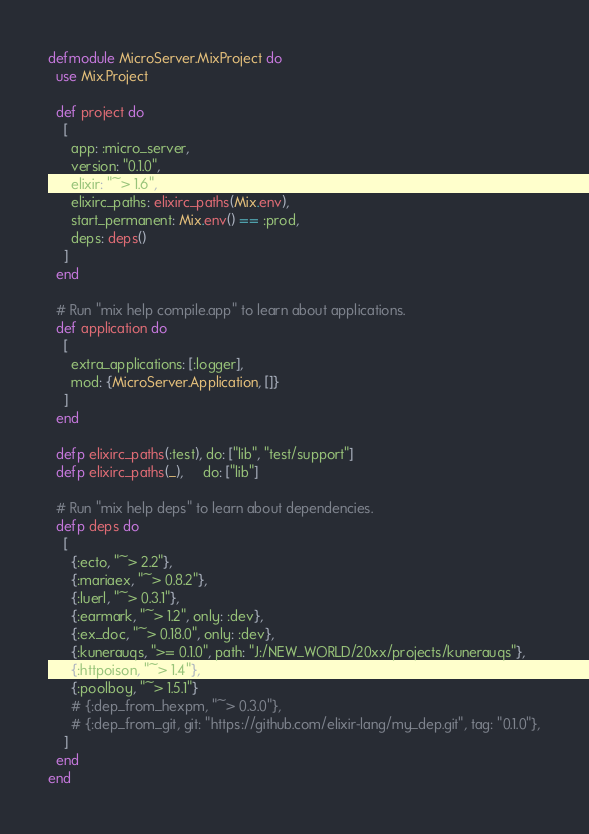Convert code to text. <code><loc_0><loc_0><loc_500><loc_500><_Elixir_>defmodule MicroServer.MixProject do
  use Mix.Project

  def project do
    [
      app: :micro_server,
      version: "0.1.0",
      elixir: "~> 1.6",
      elixirc_paths: elixirc_paths(Mix.env),
      start_permanent: Mix.env() == :prod,
      deps: deps()
    ]
  end

  # Run "mix help compile.app" to learn about applications.
  def application do
    [
      extra_applications: [:logger],
      mod: {MicroServer.Application, []}
    ]
  end

  defp elixirc_paths(:test), do: ["lib", "test/support"]
  defp elixirc_paths(_),     do: ["lib"]

  # Run "mix help deps" to learn about dependencies.
  defp deps do
    [
      {:ecto, "~> 2.2"},
      {:mariaex, "~> 0.8.2"},
      {:luerl, "~> 0.3.1"},
      {:earmark, "~> 1.2", only: :dev},
      {:ex_doc, "~> 0.18.0", only: :dev},
      {:kunerauqs, ">= 0.1.0", path: "J:/NEW_WORLD/20xx/projects/kunerauqs"},
      {:httpoison, "~> 1.4"},
      {:poolboy, "~> 1.5.1"}
      # {:dep_from_hexpm, "~> 0.3.0"},
      # {:dep_from_git, git: "https://github.com/elixir-lang/my_dep.git", tag: "0.1.0"},
    ]
  end
end
</code> 